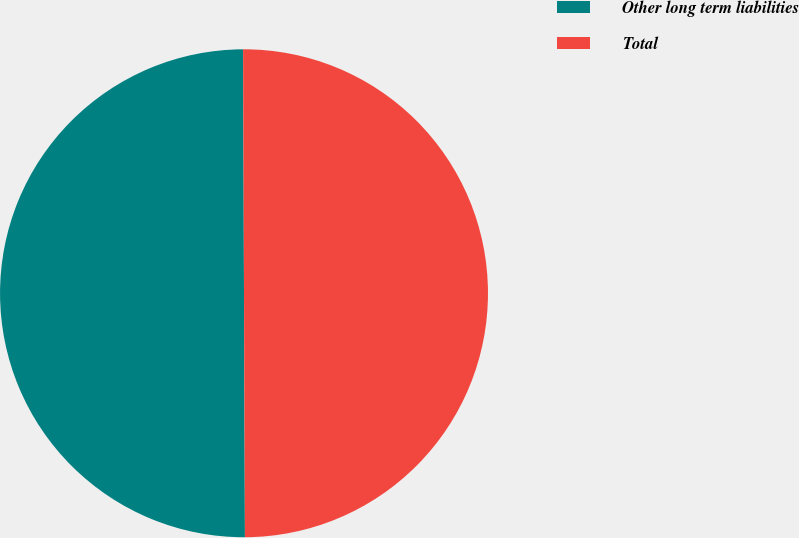Convert chart. <chart><loc_0><loc_0><loc_500><loc_500><pie_chart><fcel>Other long term liabilities<fcel>Total<nl><fcel>50.0%<fcel>50.0%<nl></chart> 